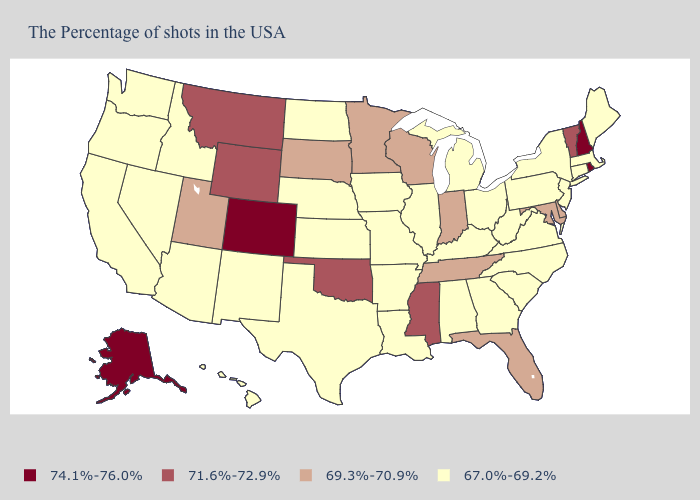Among the states that border Kentucky , does Tennessee have the lowest value?
Short answer required. No. What is the value of New Jersey?
Quick response, please. 67.0%-69.2%. Which states have the lowest value in the USA?
Be succinct. Maine, Massachusetts, Connecticut, New York, New Jersey, Pennsylvania, Virginia, North Carolina, South Carolina, West Virginia, Ohio, Georgia, Michigan, Kentucky, Alabama, Illinois, Louisiana, Missouri, Arkansas, Iowa, Kansas, Nebraska, Texas, North Dakota, New Mexico, Arizona, Idaho, Nevada, California, Washington, Oregon, Hawaii. What is the value of Maryland?
Concise answer only. 69.3%-70.9%. Name the states that have a value in the range 71.6%-72.9%?
Answer briefly. Vermont, Mississippi, Oklahoma, Wyoming, Montana. Does Alaska have the same value as Colorado?
Answer briefly. Yes. Name the states that have a value in the range 71.6%-72.9%?
Write a very short answer. Vermont, Mississippi, Oklahoma, Wyoming, Montana. Does Utah have the lowest value in the USA?
Answer briefly. No. Name the states that have a value in the range 69.3%-70.9%?
Quick response, please. Delaware, Maryland, Florida, Indiana, Tennessee, Wisconsin, Minnesota, South Dakota, Utah. Does New York have the highest value in the USA?
Answer briefly. No. What is the value of Arizona?
Answer briefly. 67.0%-69.2%. Which states hav the highest value in the Northeast?
Quick response, please. Rhode Island, New Hampshire. Name the states that have a value in the range 71.6%-72.9%?
Short answer required. Vermont, Mississippi, Oklahoma, Wyoming, Montana. Does Ohio have the same value as South Carolina?
Quick response, please. Yes. Does the map have missing data?
Write a very short answer. No. 